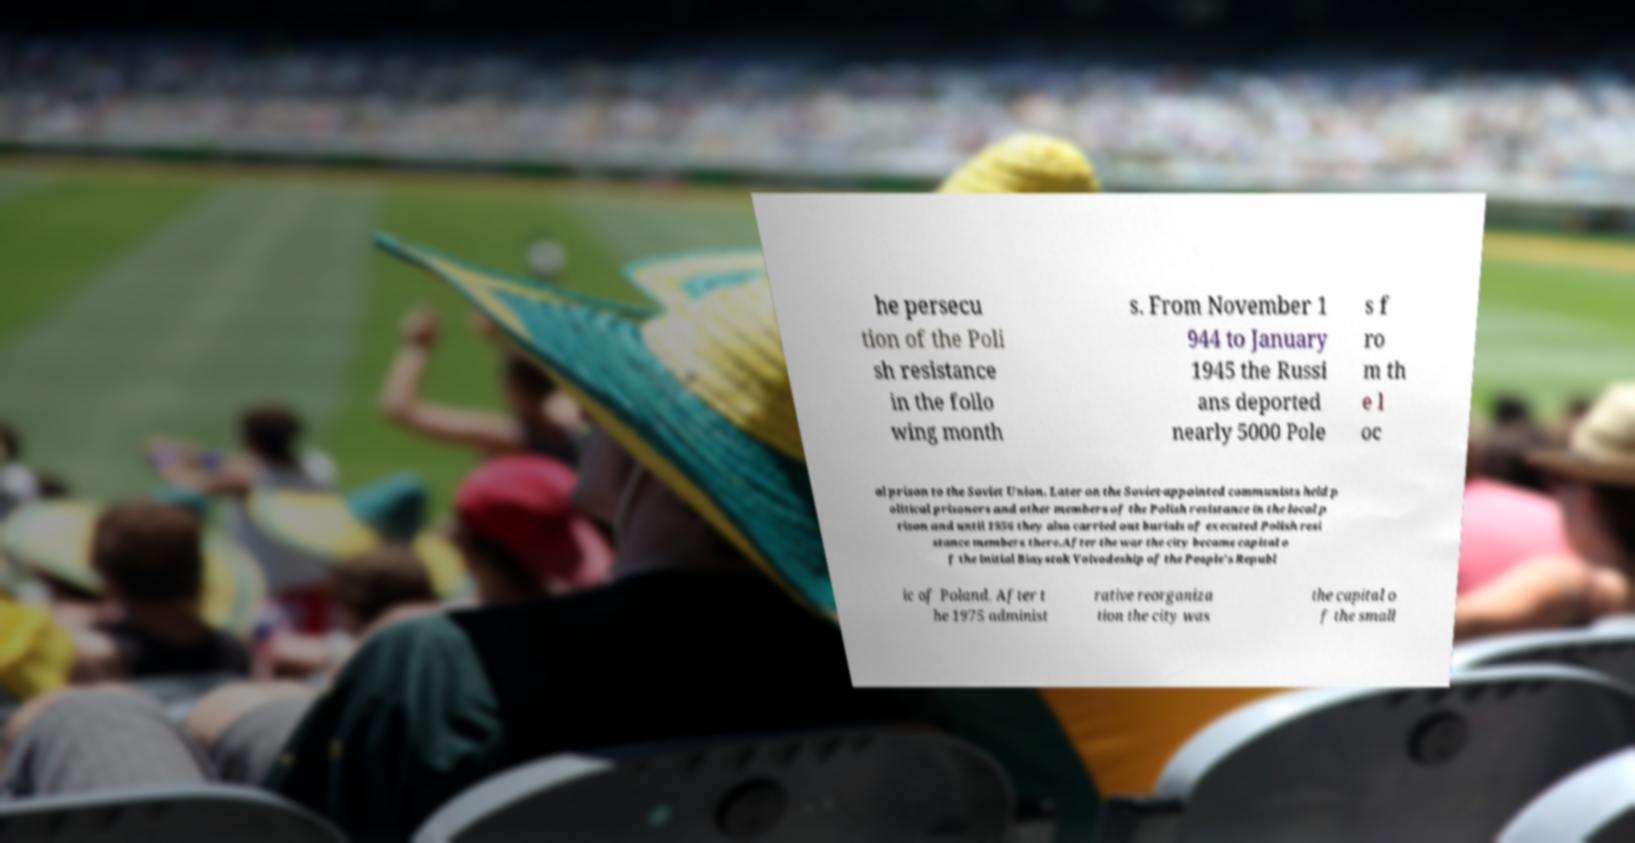For documentation purposes, I need the text within this image transcribed. Could you provide that? he persecu tion of the Poli sh resistance in the follo wing month s. From November 1 944 to January 1945 the Russi ans deported nearly 5000 Pole s f ro m th e l oc al prison to the Soviet Union. Later on the Soviet-appointed communists held p olitical prisoners and other members of the Polish resistance in the local p rison and until 1956 they also carried out burials of executed Polish resi stance members there.After the war the city became capital o f the initial Biaystok Voivodeship of the People's Republ ic of Poland. After t he 1975 administ rative reorganiza tion the city was the capital o f the small 